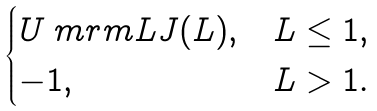Convert formula to latex. <formula><loc_0><loc_0><loc_500><loc_500>\begin{cases} U _ { \ } m r m { L J } ( L ) , & L \leq 1 , \\ - 1 , & L > 1 . \end{cases}</formula> 